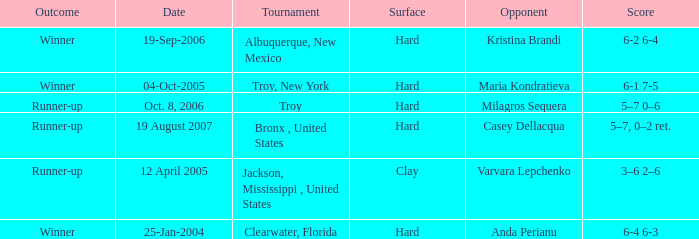Where was the tournament played on Oct. 8, 2006? Troy. 